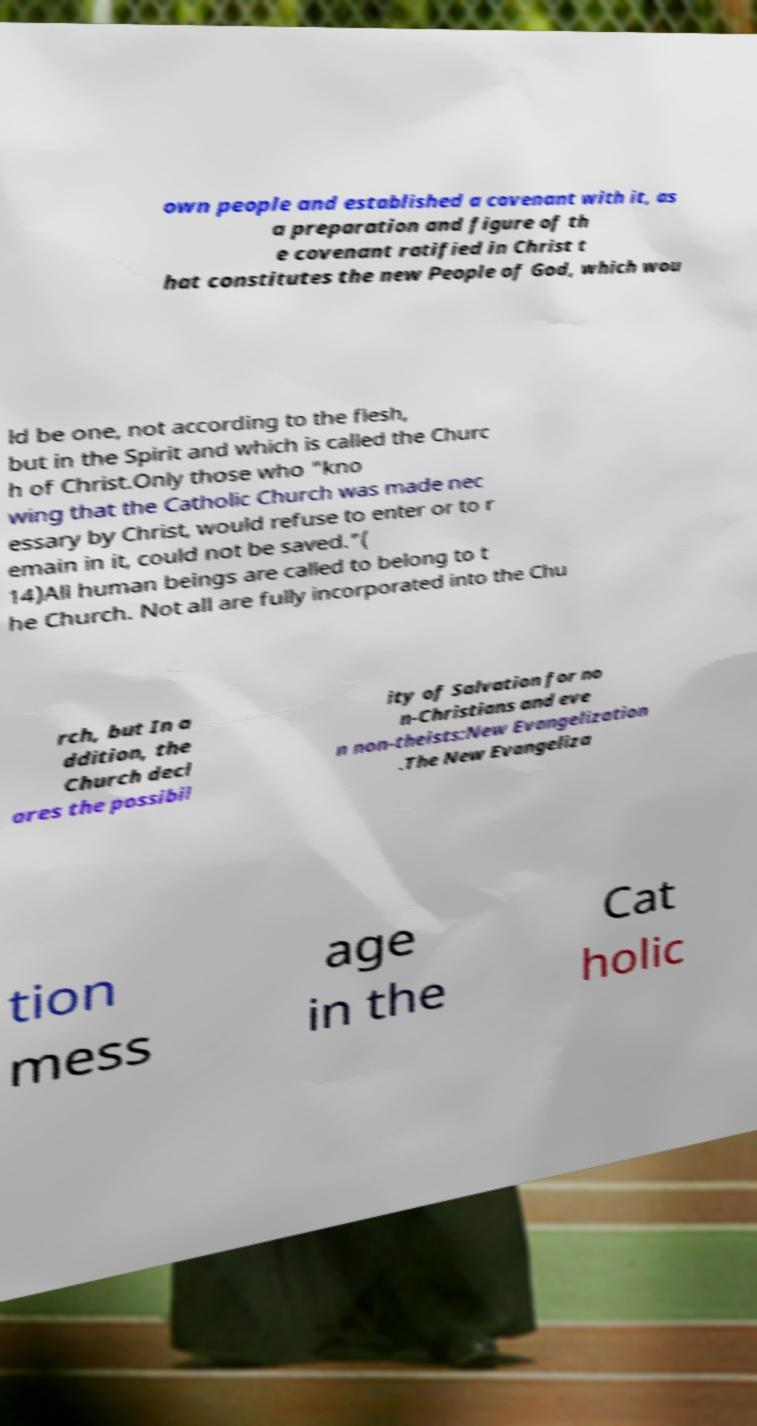Please identify and transcribe the text found in this image. own people and established a covenant with it, as a preparation and figure of th e covenant ratified in Christ t hat constitutes the new People of God, which wou ld be one, not according to the flesh, but in the Spirit and which is called the Churc h of Christ.Only those who "kno wing that the Catholic Church was made nec essary by Christ, would refuse to enter or to r emain in it, could not be saved."( 14)All human beings are called to belong to t he Church. Not all are fully incorporated into the Chu rch, but In a ddition, the Church decl ares the possibil ity of Salvation for no n-Christians and eve n non-theists:New Evangelization .The New Evangeliza tion mess age in the Cat holic 